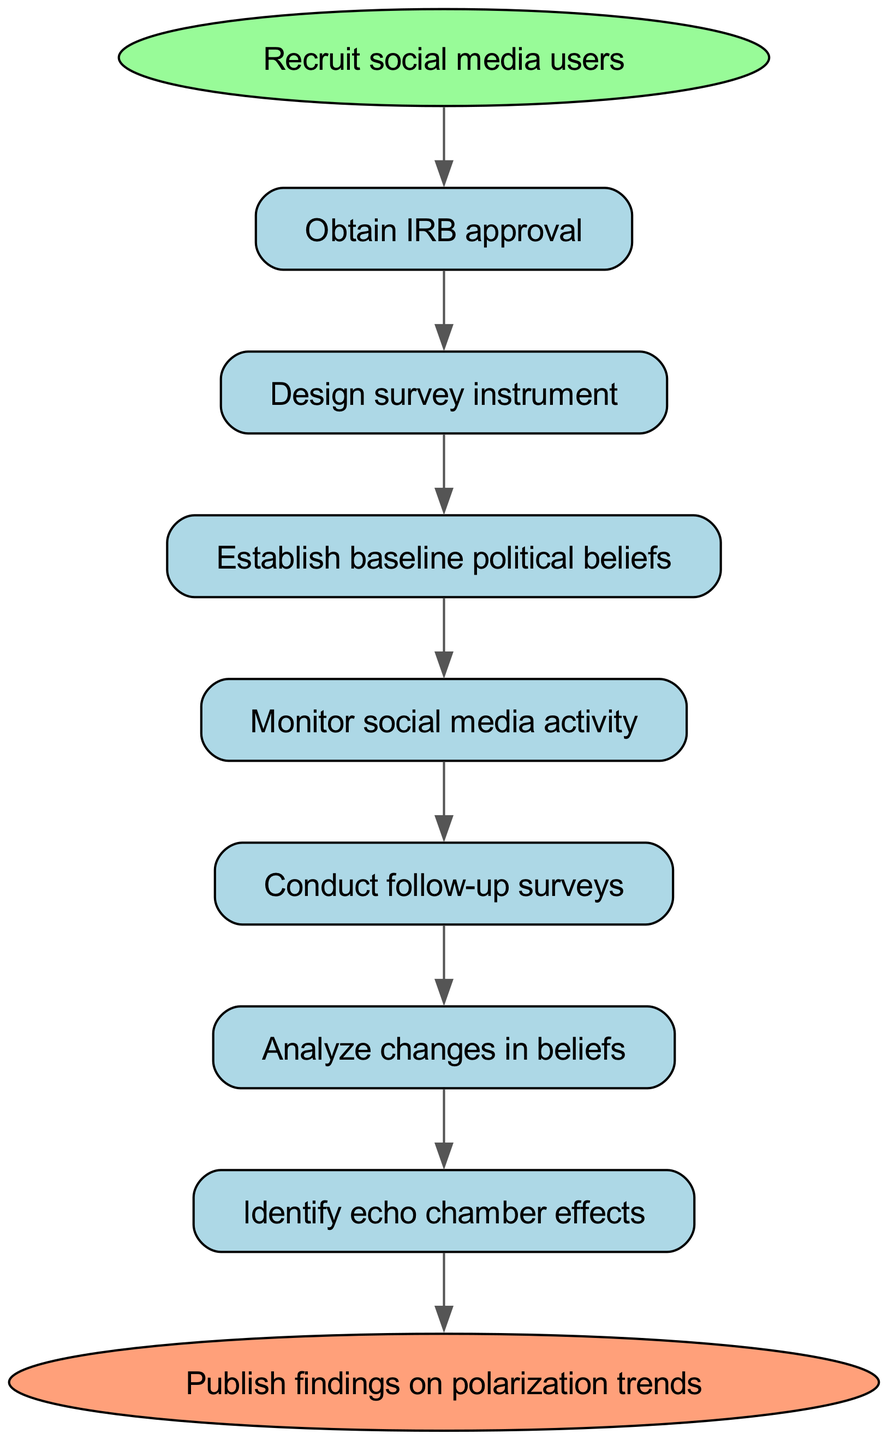What is the first step in the clinical pathway? The diagram indicates that the first step is "Recruit social media users." This is clearly labeled as the starting point in the pathway.
Answer: Recruit social media users How many total steps are there in the clinical pathway? By counting the individual steps listed in the diagram, there are seven steps before reaching the end.
Answer: 7 What is the last step in the clinical pathway? The final step in the pathway is labeled as "Publish findings on polarization trends," indicating where the process concludes.
Answer: Publish findings on polarization trends What precedes "Analyze changes in beliefs"? According to the flow of the diagram, the step directly before "Analyze changes in beliefs" is "Conduct follow-up surveys," as each step is sequentially related.
Answer: Conduct follow-up surveys Which step comes after "Identify echo chamber effects"? The step that follows "Identify echo chamber effects" is "Measure political polarization," showing a direct progression in the clinical pathway's logic.
Answer: Measure political polarization What is the relationship between "Monitor social media activity" and "Conduct follow-up surveys"? "Monitor social media activity" is a prerequisite for "Conduct follow-up surveys," meaning that the former must occur before the latter can take place, showcasing the linear progression in the pathway.
Answer: Sequential relationship How does the pathway assess changes in beliefs? Changes in beliefs are assessed by the step "Analyze changes in beliefs," which follows the "Conduct follow-up surveys," indicating that surveys are used to evaluate shifts in political beliefs over time.
Answer: Analyze changes in beliefs What is required before designing the survey instrument? Before designing the survey instrument, it is necessary to "Obtain IRB approval." This is the initial step to ensure ethical standards are met in the research.
Answer: Obtain IRB approval 